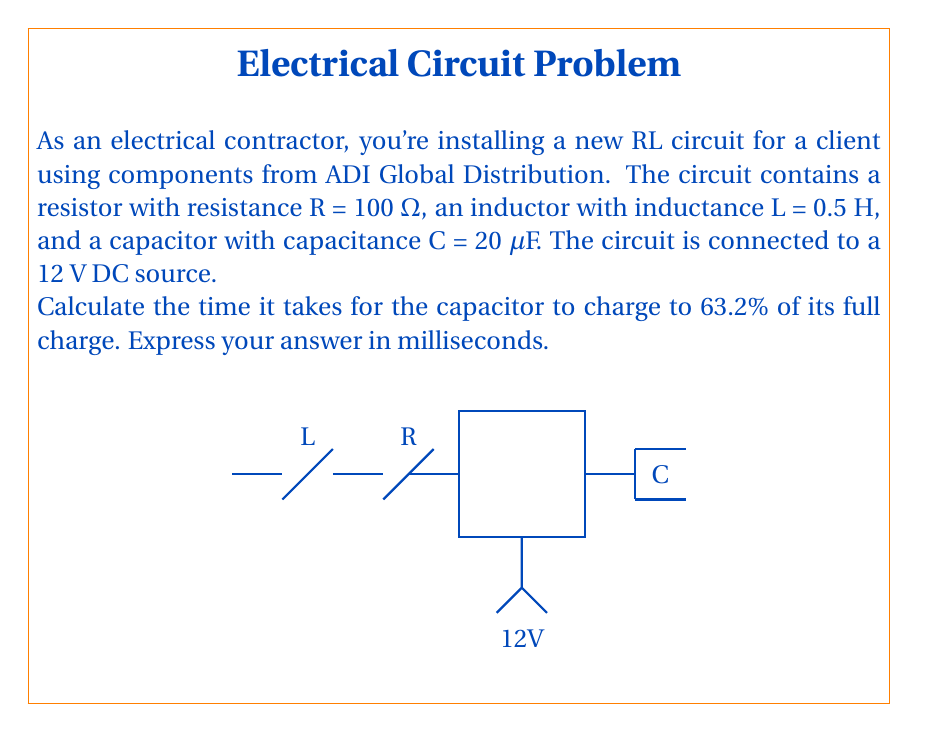Give your solution to this math problem. Let's approach this step-by-step:

1) In an RL circuit with a capacitor, the charging time constant τ is given by:

   $$τ = \frac{L}{R}$$

2) Substituting the given values:

   $$τ = \frac{0.5 \text{ H}}{100 \text{ Ω}} = 0.005 \text{ s}$$

3) The time it takes for a capacitor to charge to 63.2% of its full charge is equal to one time constant.

4) Therefore, the charging time t is:

   $$t = τ = 0.005 \text{ s}$$

5) Converting to milliseconds:

   $$t = 0.005 \text{ s} \times \frac{1000 \text{ ms}}{1 \text{ s}} = 5 \text{ ms}$$

Note: The capacitance value (C = 20 μF) given in the problem is not needed for this calculation. In an RL circuit, the charging time of the capacitor is determined by the ratio of inductance to resistance, not the capacitance.
Answer: 5 ms 